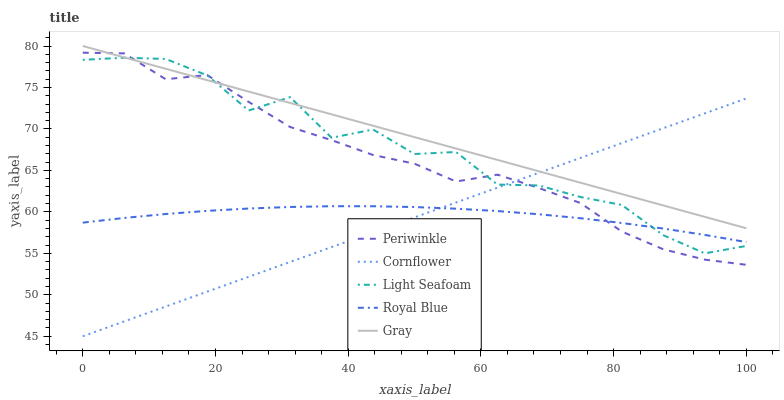Does Cornflower have the minimum area under the curve?
Answer yes or no. Yes. Does Gray have the maximum area under the curve?
Answer yes or no. Yes. Does Light Seafoam have the minimum area under the curve?
Answer yes or no. No. Does Light Seafoam have the maximum area under the curve?
Answer yes or no. No. Is Cornflower the smoothest?
Answer yes or no. Yes. Is Light Seafoam the roughest?
Answer yes or no. Yes. Is Gray the smoothest?
Answer yes or no. No. Is Gray the roughest?
Answer yes or no. No. Does Cornflower have the lowest value?
Answer yes or no. Yes. Does Light Seafoam have the lowest value?
Answer yes or no. No. Does Gray have the highest value?
Answer yes or no. Yes. Does Light Seafoam have the highest value?
Answer yes or no. No. Is Royal Blue less than Gray?
Answer yes or no. Yes. Is Gray greater than Royal Blue?
Answer yes or no. Yes. Does Cornflower intersect Periwinkle?
Answer yes or no. Yes. Is Cornflower less than Periwinkle?
Answer yes or no. No. Is Cornflower greater than Periwinkle?
Answer yes or no. No. Does Royal Blue intersect Gray?
Answer yes or no. No. 